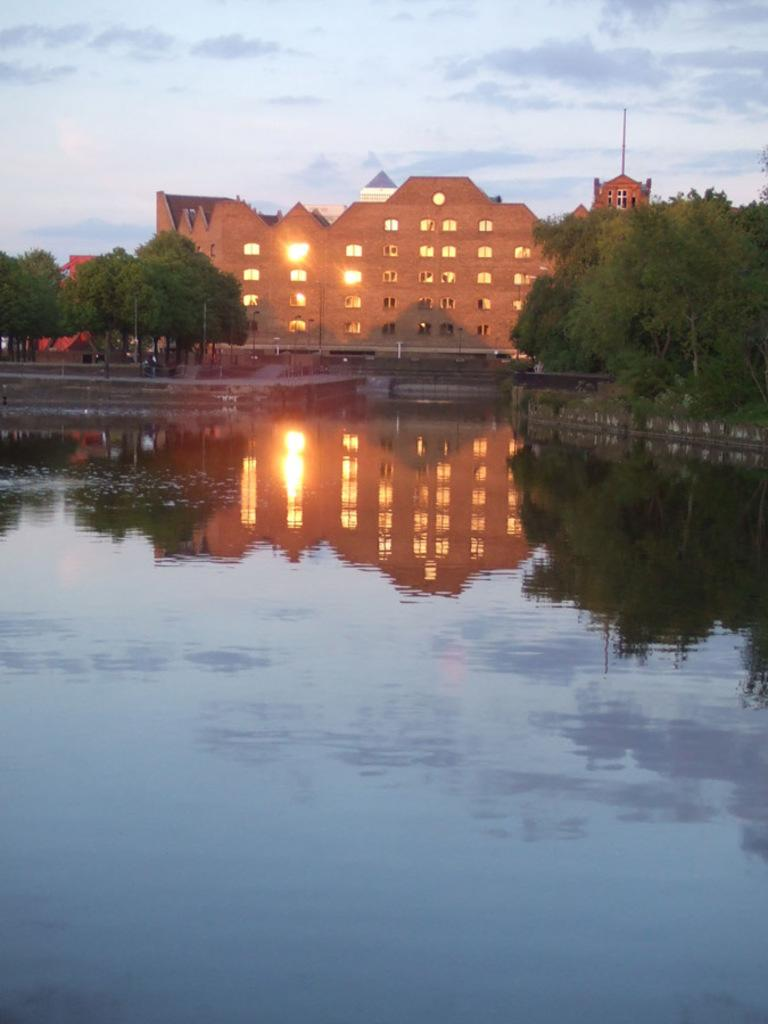What type of structure is present in the image? There is a building in the image. What feature can be seen on the building? The building has windows. What type of vegetation is present in the image? There are trees in the image. What architectural feature is visible in the image? There are stairs in the image. What natural element is visible in the image? Water is visible in the image. What part of the natural environment is visible in the image? The sky is visible in the image. What type of ball is being used for humor in the image? There is no ball or humor present in the image. 